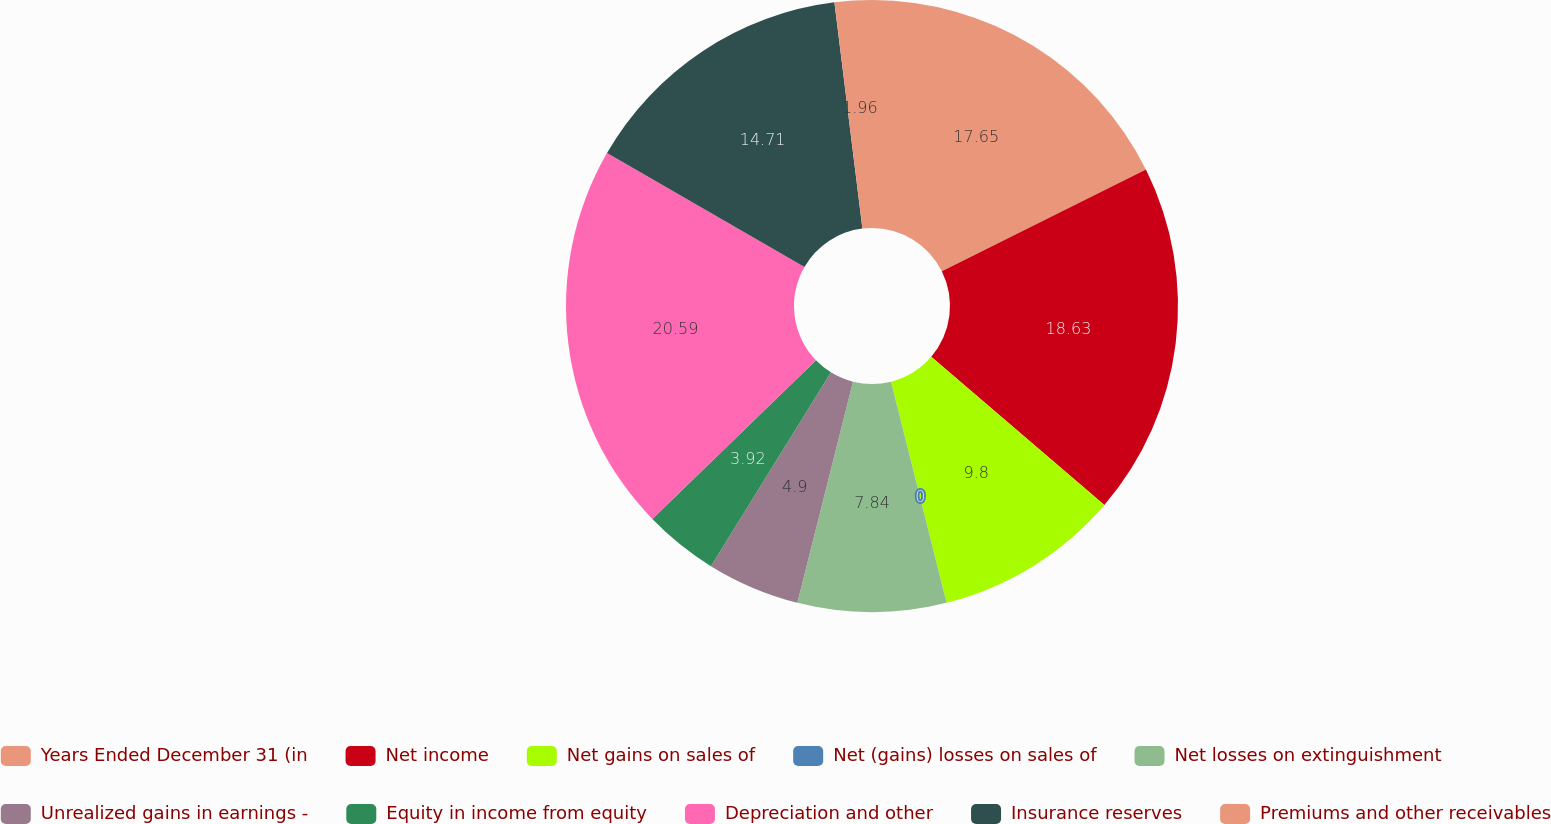Convert chart to OTSL. <chart><loc_0><loc_0><loc_500><loc_500><pie_chart><fcel>Years Ended December 31 (in<fcel>Net income<fcel>Net gains on sales of<fcel>Net (gains) losses on sales of<fcel>Net losses on extinguishment<fcel>Unrealized gains in earnings -<fcel>Equity in income from equity<fcel>Depreciation and other<fcel>Insurance reserves<fcel>Premiums and other receivables<nl><fcel>17.64%<fcel>18.62%<fcel>9.8%<fcel>0.0%<fcel>7.84%<fcel>4.9%<fcel>3.92%<fcel>20.58%<fcel>14.7%<fcel>1.96%<nl></chart> 